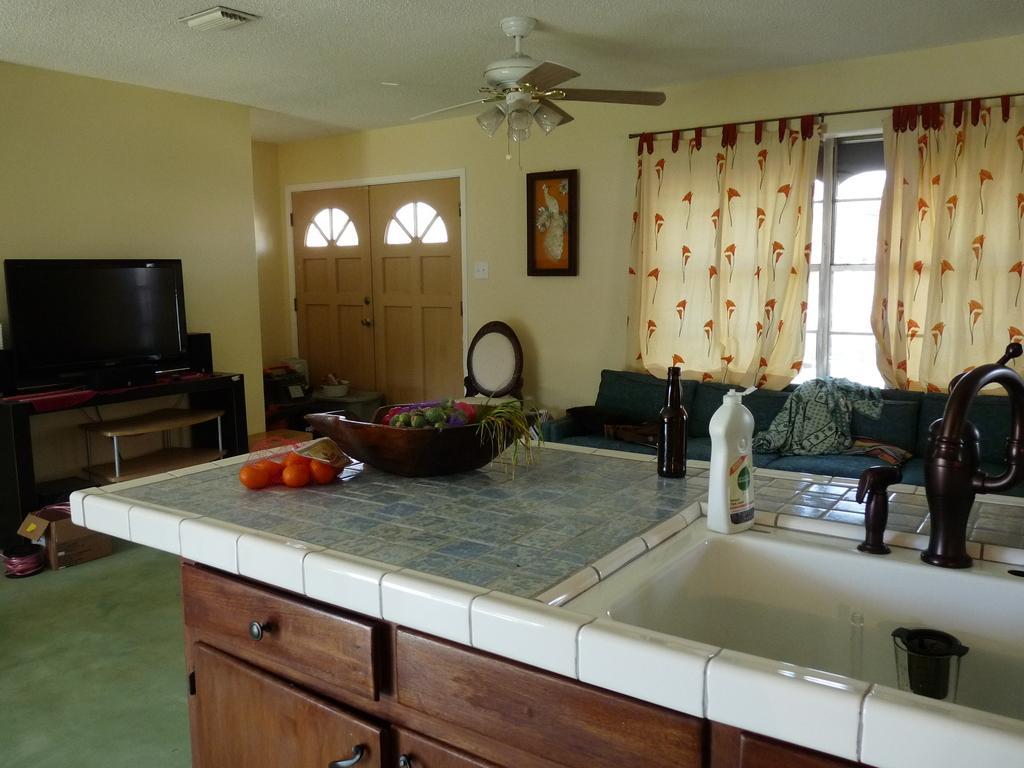Describe this image in one or two sentences. This is the picture of a room where we have a television on the desk to the left side and a door, window and a frame to the right side and in between there is a desk on which there is a bowl and some things placed on it and also a sofa to the window side. 